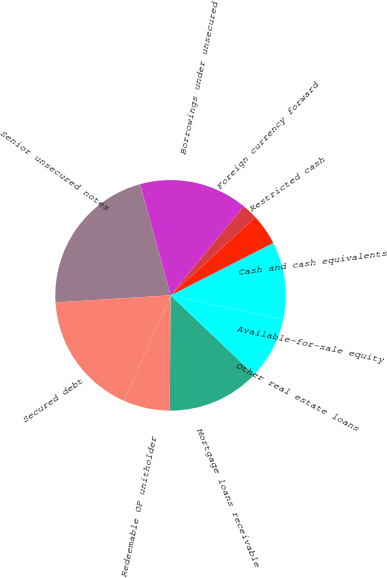Convert chart to OTSL. <chart><loc_0><loc_0><loc_500><loc_500><pie_chart><fcel>Mortgage loans receivable<fcel>Other real estate loans<fcel>Available-for-sale equity<fcel>Cash and cash equivalents<fcel>Restricted cash<fcel>Foreign currency forward<fcel>Borrowings under unsecured<fcel>Senior unsecured notes<fcel>Secured debt<fcel>Redeemable OP unitholder<nl><fcel>13.04%<fcel>8.7%<fcel>0.02%<fcel>10.87%<fcel>4.36%<fcel>2.19%<fcel>15.21%<fcel>21.72%<fcel>17.38%<fcel>6.53%<nl></chart> 